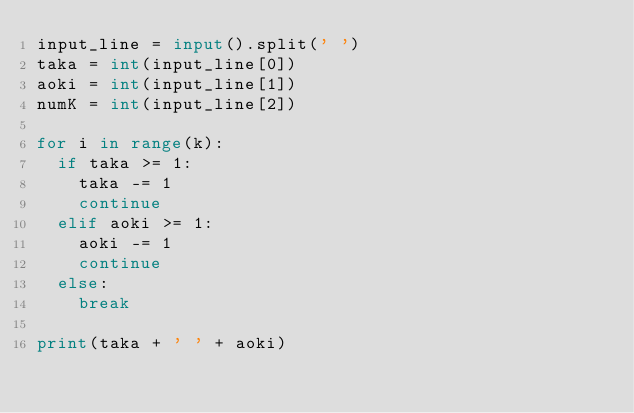<code> <loc_0><loc_0><loc_500><loc_500><_Python_>input_line = input().split(' ')
taka = int(input_line[0])
aoki = int(input_line[1])
numK = int(input_line[2])

for i in range(k):
  if taka >= 1:
    taka -= 1
    continue
  elif aoki >= 1:
    aoki -= 1
    continue
  else:
    break

print(taka + ' ' + aoki)</code> 